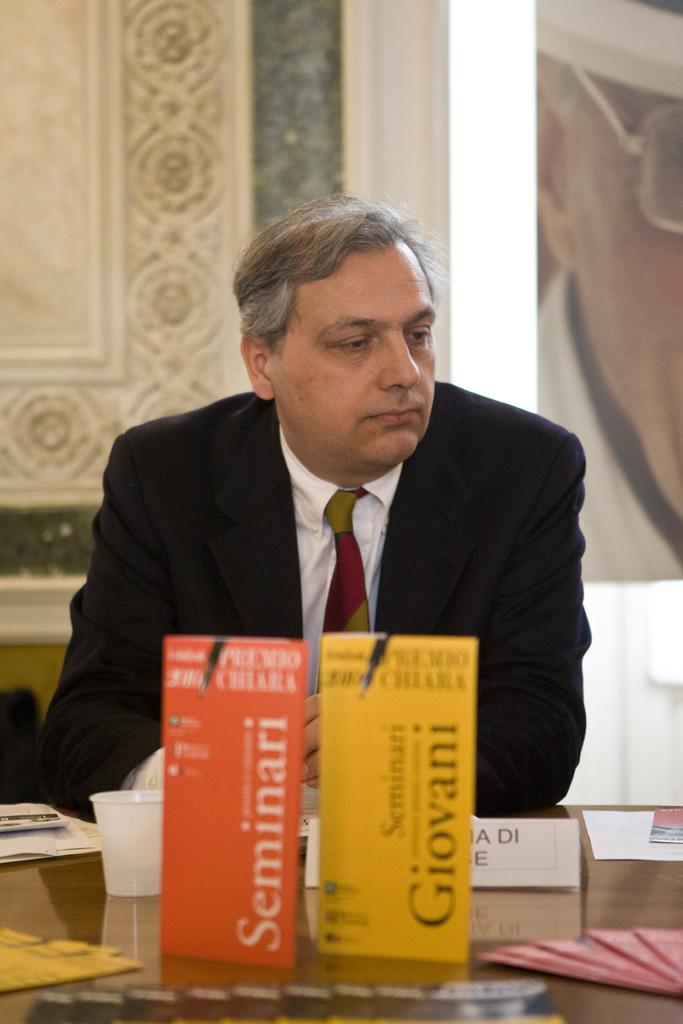<image>
Give a short and clear explanation of the subsequent image. an elderly man in a suit sitting in front of a orange seminari and a yellow giovani box. 